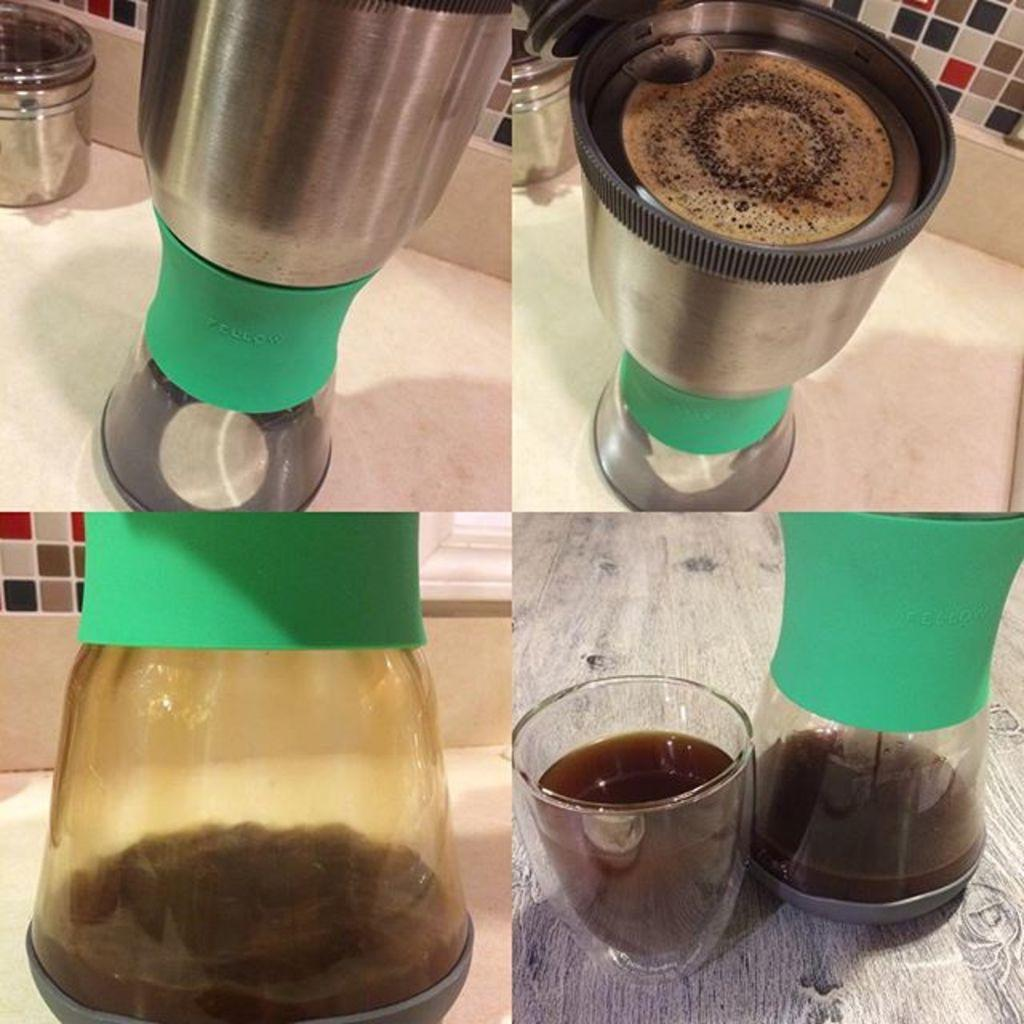What type of kitchen appliance is visible in the image? There are mixer jars in the image. What can be seen in the background of the image? There is a wall in the background of the image. What type of beverage might be in the glass? The image shows a glass with a drink, but the specific beverage cannot be determined from the image. How many ants are crawling on the mixer jars in the image? There are no ants visible in the image; it only shows mixer jars, a wall, and a glass with a drink. What type of doll is sitting on the wall in the image? There is no doll present in the image; it only shows mixer jars, a wall, and a glass with a drink. 